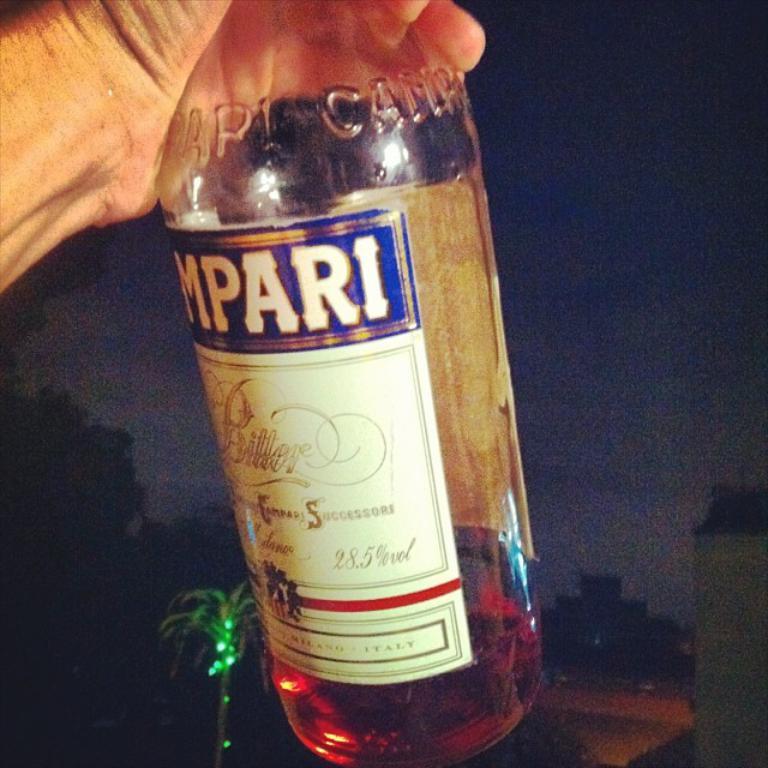What brand of alcohol is this?
Your answer should be compact. Mpari. 